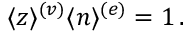Convert formula to latex. <formula><loc_0><loc_0><loc_500><loc_500>\begin{array} { r } { \langle z \rangle ^ { ( v ) } \langle n \rangle ^ { ( e ) } = 1 \, . } \end{array}</formula> 